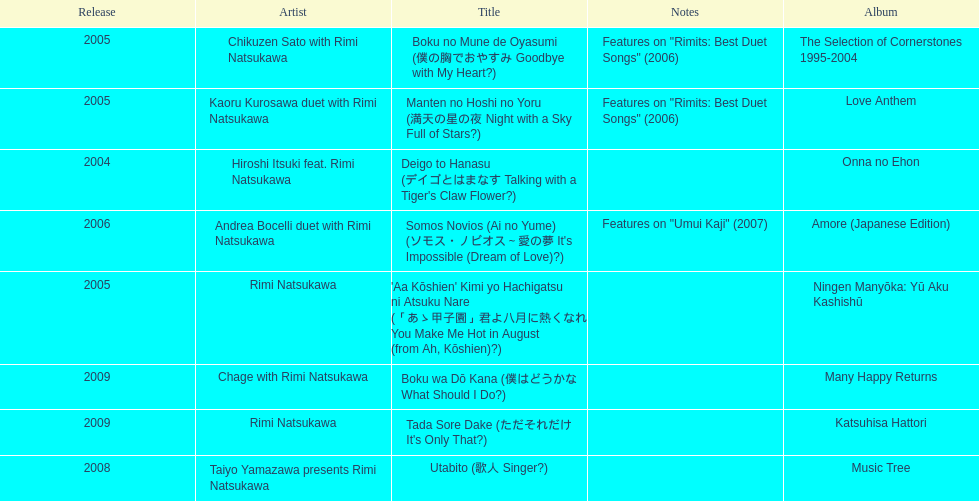What has been the last song this artist has made an other appearance on? Tada Sore Dake. 